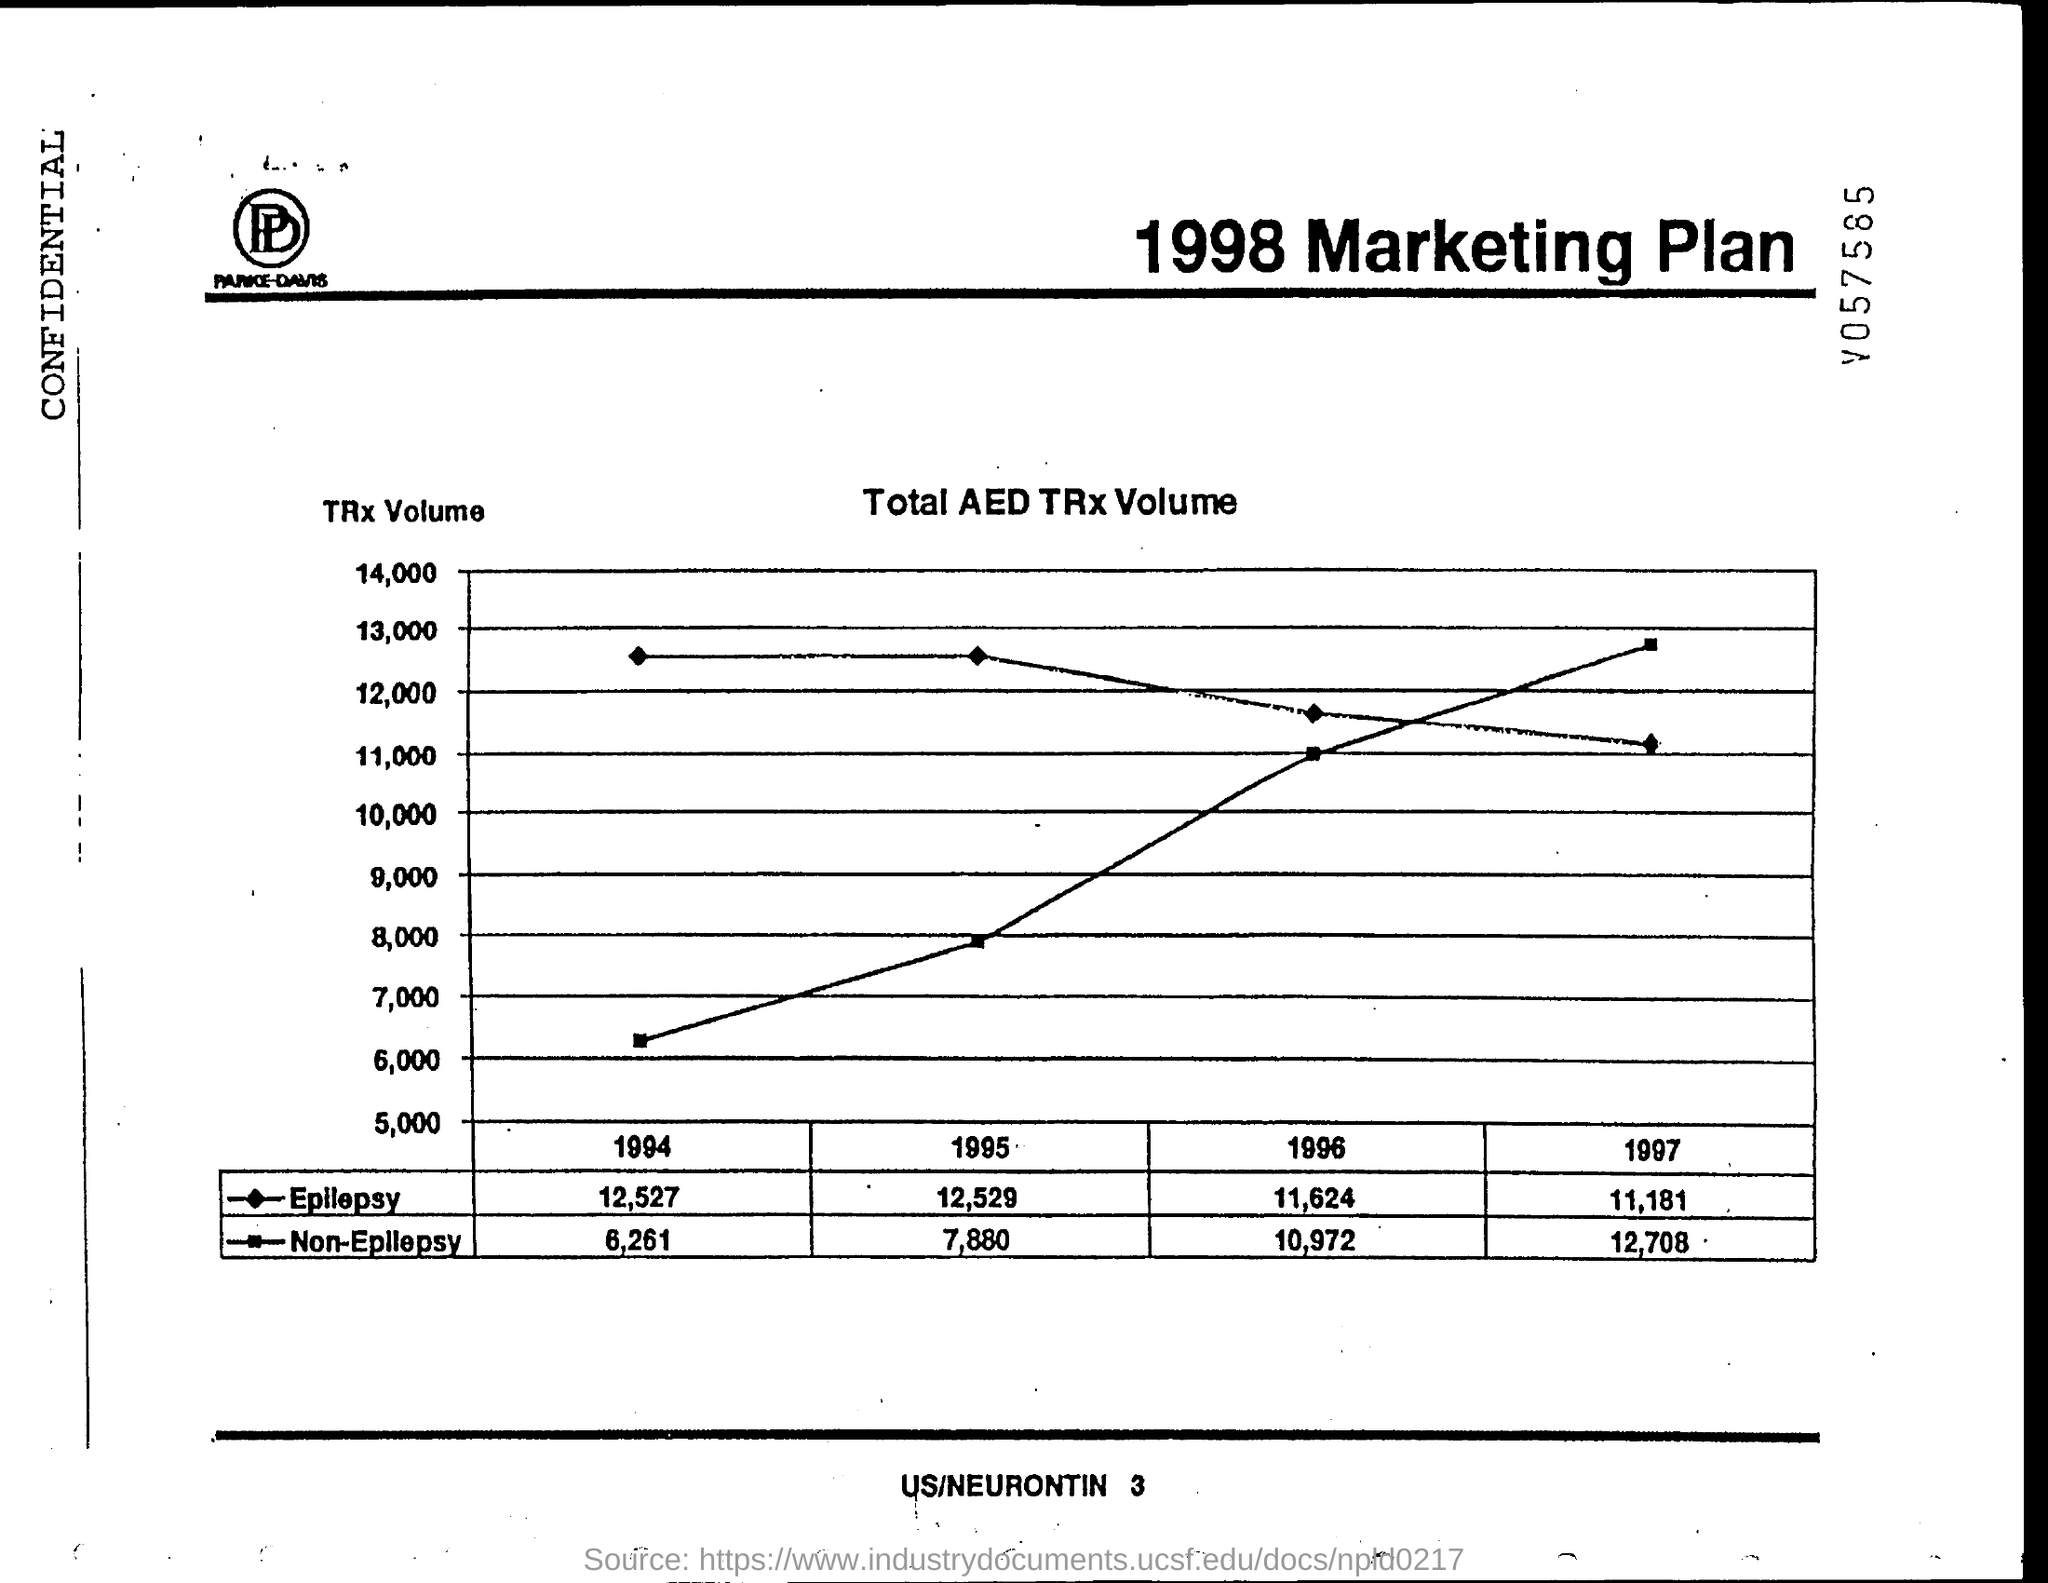What is the Total AED TRx Volume for epilepsy for 1994?
Ensure brevity in your answer.  12,527. What is the Total AED TRx Volume for epilepsy for 1995?
Your answer should be very brief. 12,529. What is the Total AED TRx Volume for epilepsy for 1996?
Provide a succinct answer. 11,624. What is the Total AED TRx Volume for epilepsy for 1997?
Provide a succinct answer. 11,181. What is the Total AED TRx Volume for Non-epilepsy for 1994?
Your answer should be very brief. 6,261. What is the Total AED TRx Volume for Non-epilepsy for 1995?
Your answer should be very brief. 7,880. What is the Total AED TRx Volume for Non-epilepsy for 1996?
Keep it short and to the point. 10,972. What is the Total AED TRx Volume for Non-epilepsy for 1997?
Keep it short and to the point. 12,708. 